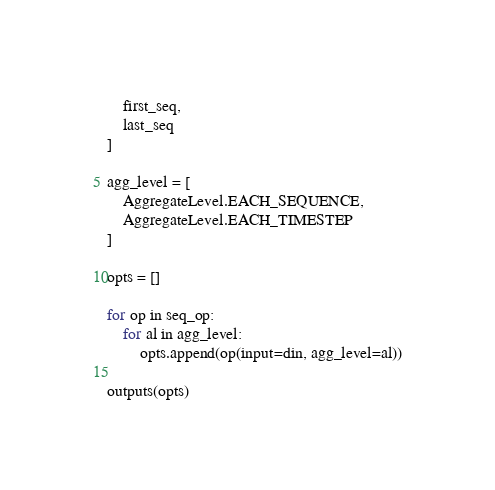<code> <loc_0><loc_0><loc_500><loc_500><_Python_>    first_seq,
    last_seq
]

agg_level = [
    AggregateLevel.EACH_SEQUENCE,
    AggregateLevel.EACH_TIMESTEP
]

opts = []

for op in seq_op:
    for al in agg_level:
        opts.append(op(input=din, agg_level=al))

outputs(opts)</code> 